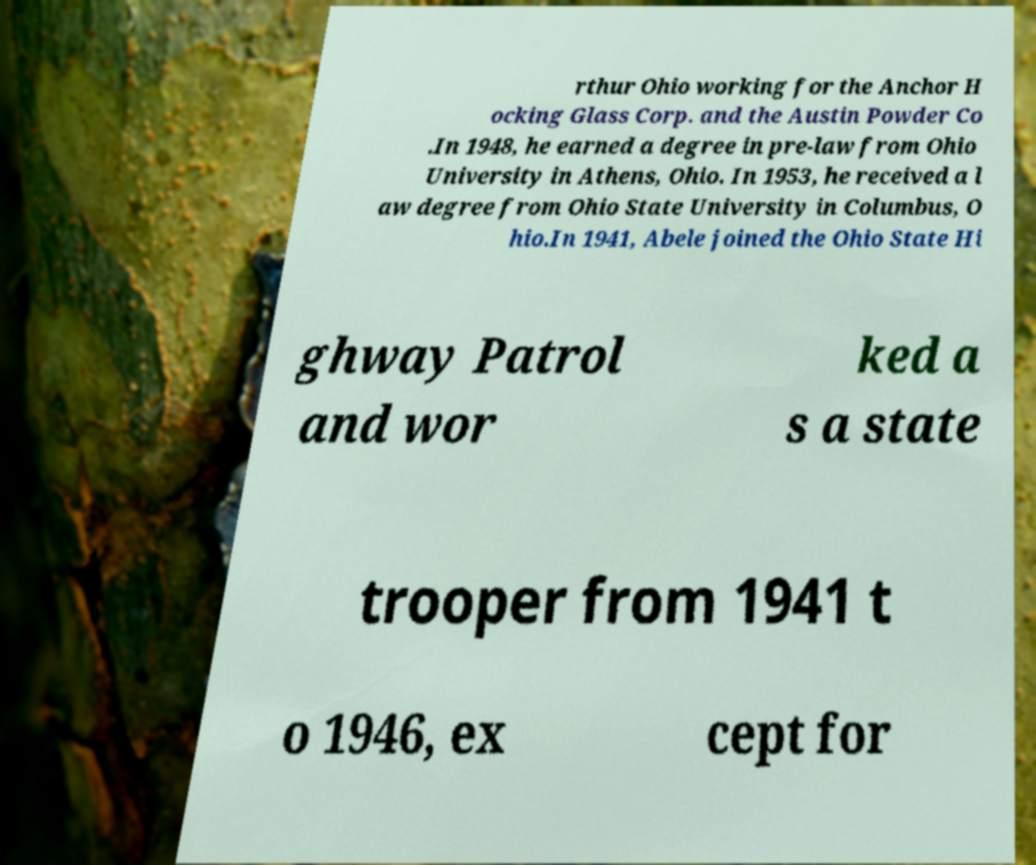Please identify and transcribe the text found in this image. rthur Ohio working for the Anchor H ocking Glass Corp. and the Austin Powder Co .In 1948, he earned a degree in pre-law from Ohio University in Athens, Ohio. In 1953, he received a l aw degree from Ohio State University in Columbus, O hio.In 1941, Abele joined the Ohio State Hi ghway Patrol and wor ked a s a state trooper from 1941 t o 1946, ex cept for 